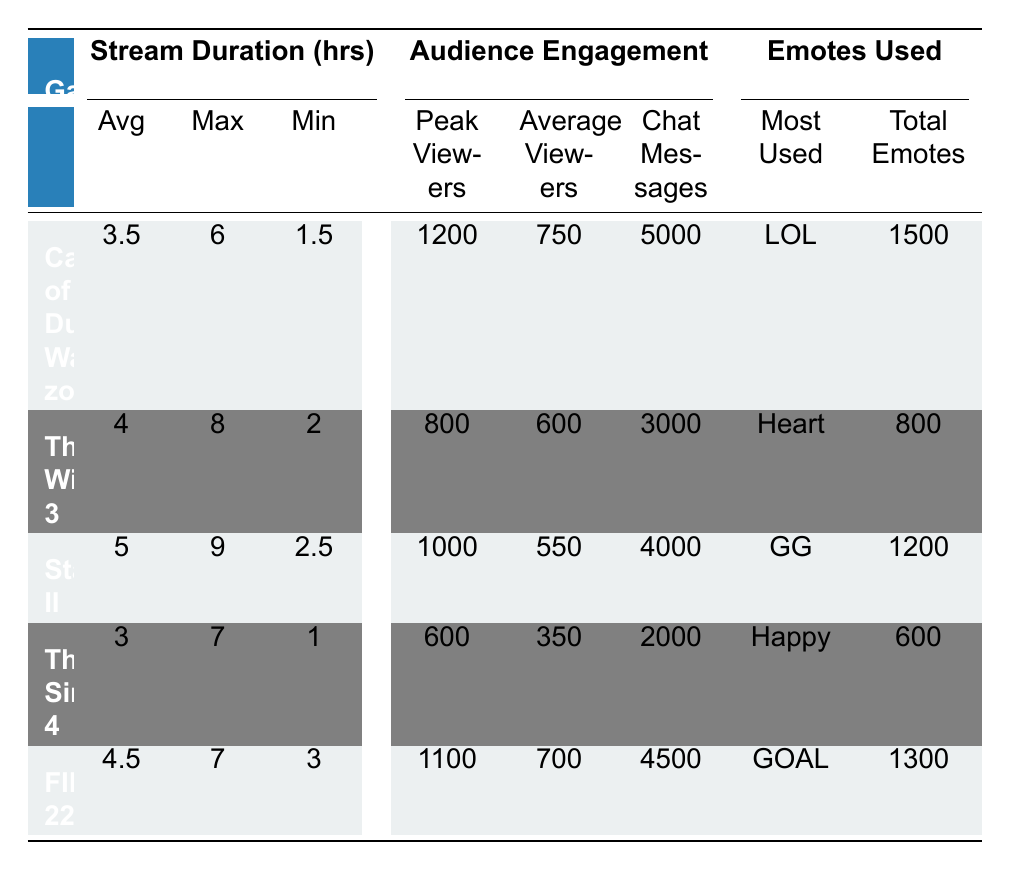What is the maximum stream duration for "The Witcher 3"? The maximum stream duration for "The Witcher 3" is listed in the table under the "Max" column corresponding to the game type. It is 8 hours.
Answer: 8 hours How many peak viewers did "FIFA 22" have? The peak viewers for "FIFA 22" can be found under the "Peak Viewers" column for that game type in the table, which is 1100.
Answer: 1100 Which game had the highest average viewers? To find this, compare the "Average Viewers" for all games in the table. "Call of Duty: Warzone" has 750, "The Witcher 3" has 600, "Starcraft II" has 550, "The Sims 4" has 350, and "FIFA 22" has 700. Therefore, "Call of Duty: Warzone" has the highest average viewers.
Answer: Call of Duty: Warzone What is the average stream duration for the games listed? Calculate the average by adding the average stream durations: (3.5 + 4 + 5 + 3 + 4.5) = 20 hours. Since there are 5 games, divide by 5: 20/5 = 4.
Answer: 4 hours Did "The Sims 4" have more chat messages than "The Witcher 3"? Check the "Chat Messages" column. "The Sims 4" has 2000 chat messages, while "The Witcher 3" has 3000. Since 2000 is less than 3000, it did not have more chat messages.
Answer: No Which game had the most used emote and what was it? The "Most Used" emote is listed in the table under the "Emotes Used" section. "Call of Duty: Warzone" has "LOL" as the most used emote.
Answer: LOL What is the difference in peak viewers between "Starcraft II" and "The Sims 4"? The peak viewers for "Starcraft II" is 1000, and for "The Sims 4" it is 600. The difference is 1000 - 600 = 400.
Answer: 400 Which game type had the least amount of total emotes used? Compare the "Total Emotes" column. "The Sims 4" has 600 total emotes, which is the lowest compared to the others: 1500, 800, 1200, and 1300.
Answer: The Sims 4 What is the average number of chat messages for "Action" type games? Only "Call of Duty: Warzone" and "FIFA 22" fall under Action. Their chat messages are 5000 and 4500 respectively. The average is (5000 + 4500) / 2 = 4750.
Answer: 4750 Is the average stream duration for RPG games greater than Action games? The table shows "The Witcher 3" (RPG) has 4 hours, while "Call of Duty: Warzone" (Action) has 3.5 hours. 4 hours is greater than 3.5 hours, so the answer is yes.
Answer: Yes 